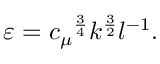<formula> <loc_0><loc_0><loc_500><loc_500>\varepsilon = { c _ { \mu } } ^ { \frac { 3 } { 4 } } k ^ { \frac { 3 } { 2 } } l ^ { - 1 } .</formula> 